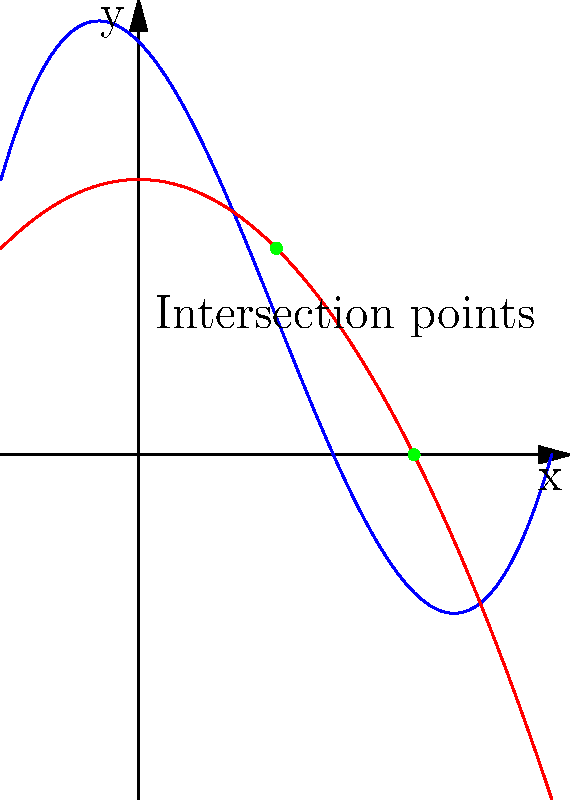In a church labyrinth, two curved paths symbolize the journey of faith and grace. These paths are represented by the polynomials $f(x) = 0.5x^3 - 1.5x^2 - x + 3$ (Path of Faith) and $g(x) = -0.5x^2 + 2$ (Path of Grace). At which points do these paths intersect, and how do these intersection points relate to the zeroes of a new polynomial? To find the intersection points, we need to solve the equation $f(x) = g(x)$:

1) $0.5x^3 - 1.5x^2 - x + 3 = -0.5x^2 + 2$

2) Rearranging the equation:
   $0.5x^3 - x^2 - x + 1 = 0$

3) This new equation represents a polynomial $h(x) = 0.5x^3 - x^2 - x + 1$

4) The zeroes of $h(x)$ are the x-coordinates of the intersection points of $f(x)$ and $g(x)$

5) Using the quadratic formula or factoring, we can find that $h(x)$ has zeroes at $x = 1$ and $x = 2$

6) Substituting these x-values back into either $f(x)$ or $g(x)$, we get:
   At $x = 1$: $f(1) = g(1) = 1.5$
   At $x = 2$: $f(2) = g(2) = 0$

7) Therefore, the intersection points are $(1, 1.5)$ and $(2, 0)$

8) These points represent where the paths of faith and grace meet in the labyrinth, symbolizing moments of divine connection in the Christian journey.
Answer: $(1, 1.5)$ and $(2, 0)$; they are the zeroes of $h(x) = 0.5x^3 - x^2 - x + 1$ 